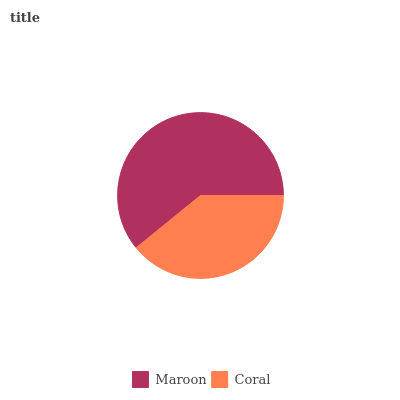Is Coral the minimum?
Answer yes or no. Yes. Is Maroon the maximum?
Answer yes or no. Yes. Is Coral the maximum?
Answer yes or no. No. Is Maroon greater than Coral?
Answer yes or no. Yes. Is Coral less than Maroon?
Answer yes or no. Yes. Is Coral greater than Maroon?
Answer yes or no. No. Is Maroon less than Coral?
Answer yes or no. No. Is Maroon the high median?
Answer yes or no. Yes. Is Coral the low median?
Answer yes or no. Yes. Is Coral the high median?
Answer yes or no. No. Is Maroon the low median?
Answer yes or no. No. 